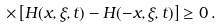<formula> <loc_0><loc_0><loc_500><loc_500>\times \left [ H ( x , \xi , t ) - H ( - x , \xi , t ) \right ] \geq 0 \, .</formula> 